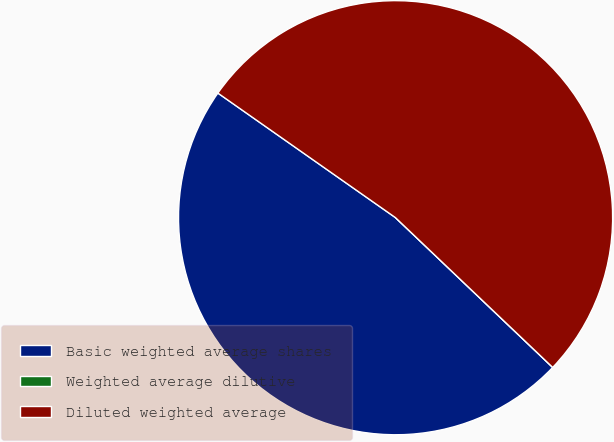Convert chart to OTSL. <chart><loc_0><loc_0><loc_500><loc_500><pie_chart><fcel>Basic weighted average shares<fcel>Weighted average dilutive<fcel>Diluted weighted average<nl><fcel>47.62%<fcel>0.0%<fcel>52.38%<nl></chart> 